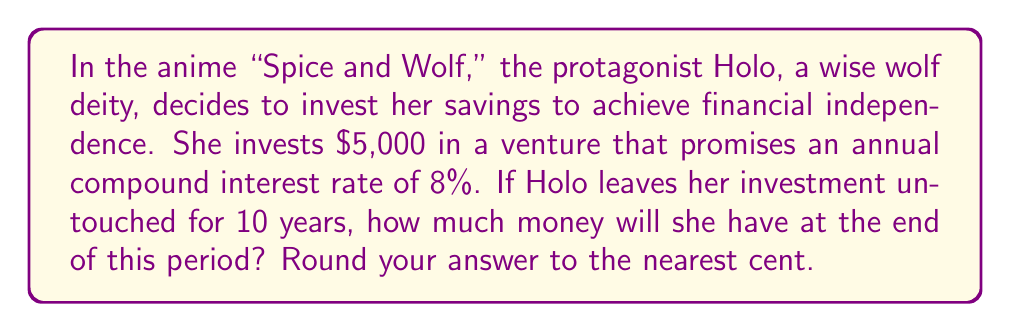Could you help me with this problem? To solve this problem, we'll use the compound interest formula:

$$A = P(1 + r)^n$$

Where:
$A$ = Final amount
$P$ = Principal (initial investment)
$r$ = Annual interest rate (in decimal form)
$n$ = Number of years

Given:
$P = 5000$
$r = 0.08$ (8% converted to decimal)
$n = 10$ years

Let's substitute these values into the formula:

$$A = 5000(1 + 0.08)^{10}$$

Now, let's calculate step by step:

1) First, calculate $(1 + 0.08)$:
   $1 + 0.08 = 1.08$

2) Now, we need to calculate $1.08^{10}$:
   $1.08^{10} \approx 2.1589$

3) Finally, multiply this by the principal:
   $5000 \times 2.1589 = 10,794.50$

Therefore, after 10 years, Holo's investment will grow to $10,794.50.
Answer: $10,794.50 